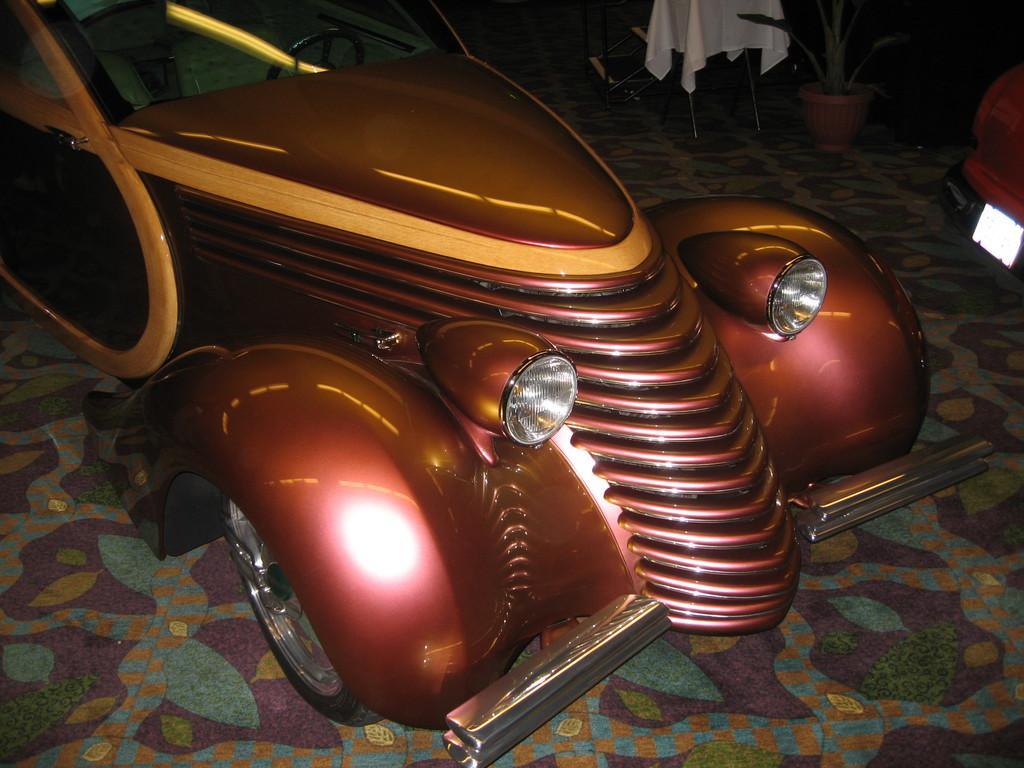How would you summarize this image in a sentence or two? In the foreground of this image, there is a car on the floor. It seems like a vehicle on the right. At the top, there is a potted plant and it seems like a white cloth on a chair. 